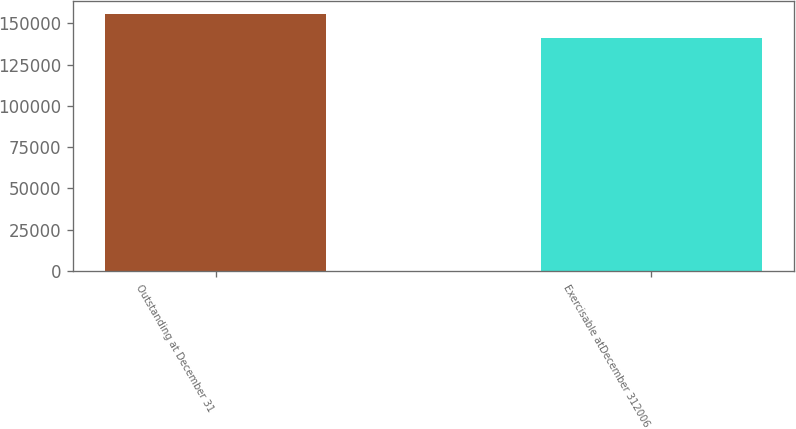Convert chart. <chart><loc_0><loc_0><loc_500><loc_500><bar_chart><fcel>Outstanding at December 31<fcel>Exercisable atDecember 312006<nl><fcel>155715<fcel>140829<nl></chart> 